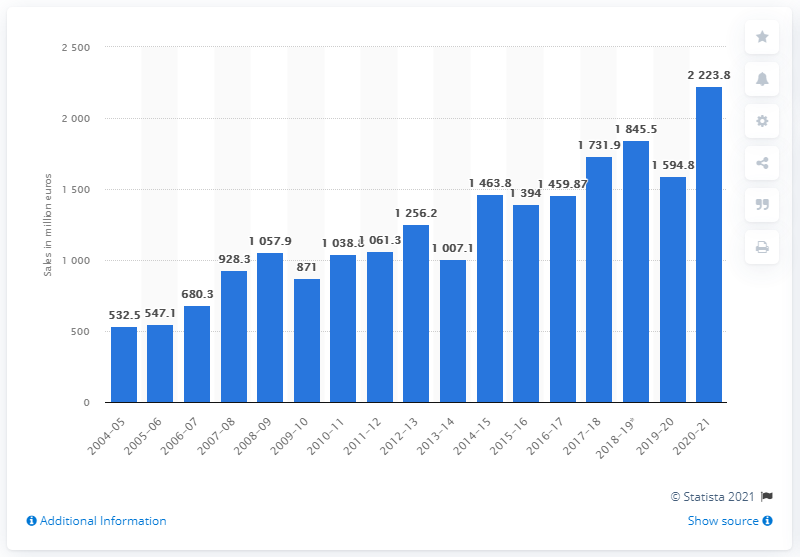Give some essential details in this illustration. Ubisoft generated $2,223.8 million in sales during the fiscal year 2020-21. In Ubisoft's previous fiscal year, approximately 12.562% of the company's sales were attributed to the digital format. 